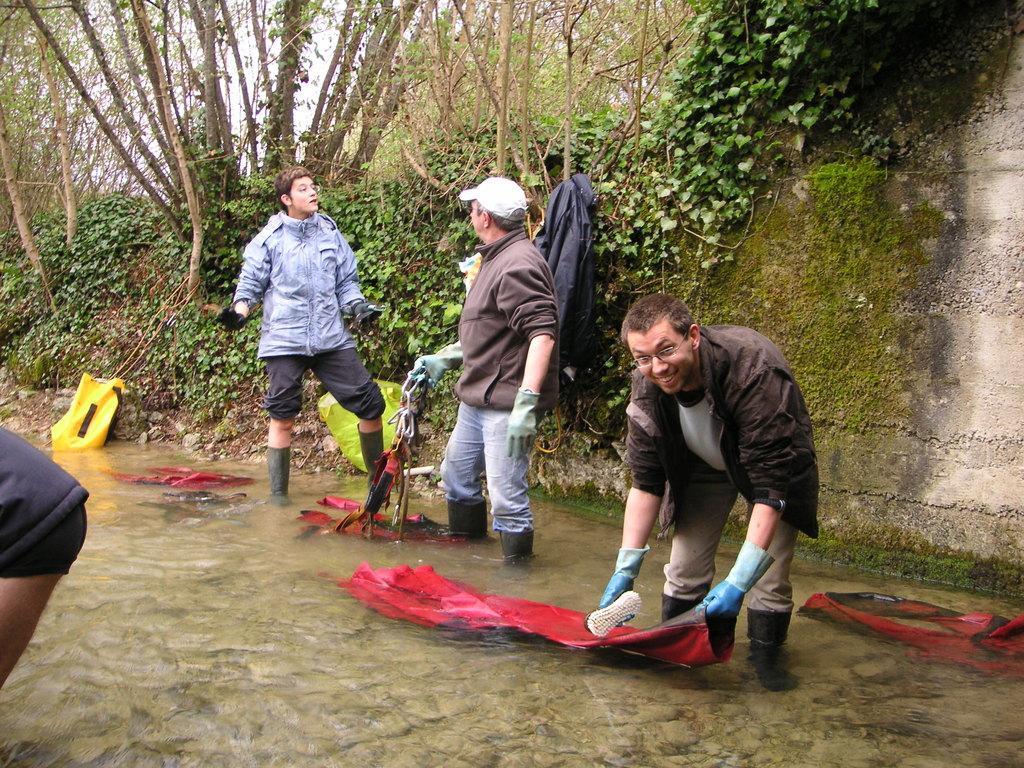Can you describe this image briefly? In this picture, we see three people standing in water. The man on the right corner of the picture wearing black jacket is holding a red color sheet and a brush in his hands and he is smiling. Beside him, the man in brown jacket who is wearing a cap is holding something in his hand and he is talking to the man on the opposite side who is wearing a blue jacket. Beside them, we see a yellow color bag and there are many trees in the background. 